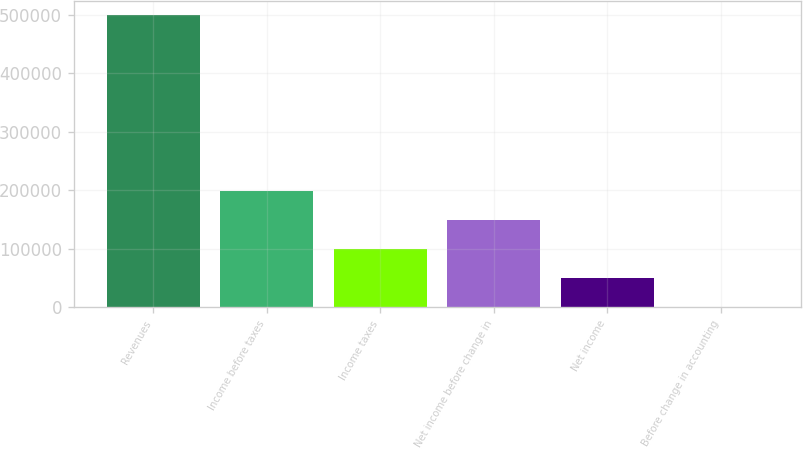Convert chart. <chart><loc_0><loc_0><loc_500><loc_500><bar_chart><fcel>Revenues<fcel>Income before taxes<fcel>Income taxes<fcel>Net income before change in<fcel>Net income<fcel>Before change in accounting<nl><fcel>499158<fcel>199663<fcel>99831.6<fcel>149747<fcel>49915.8<fcel>0.03<nl></chart> 